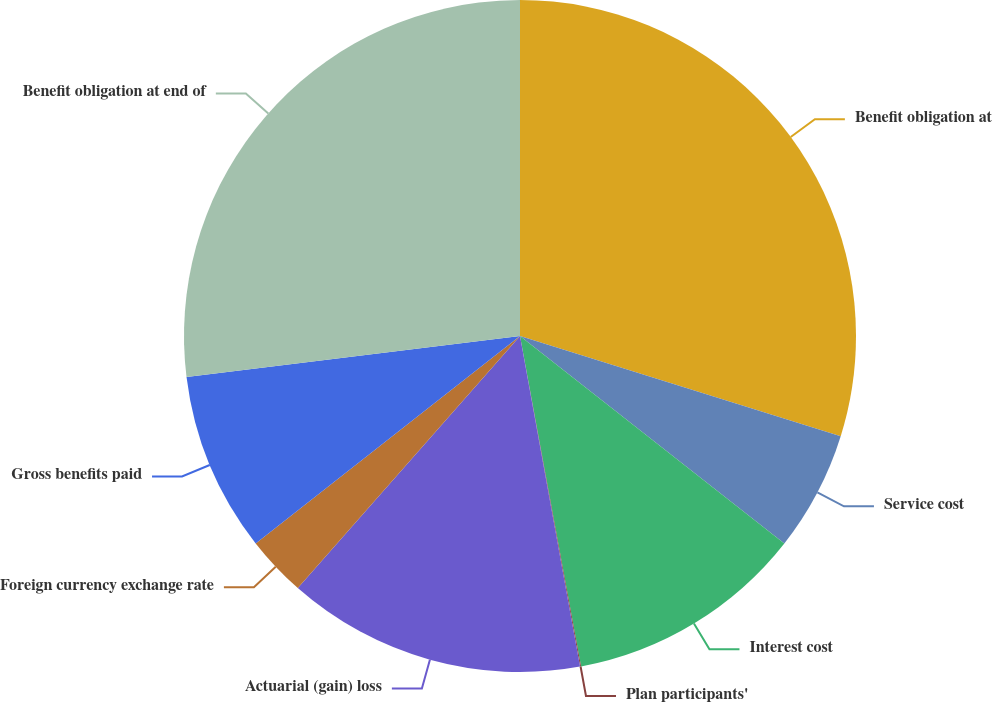<chart> <loc_0><loc_0><loc_500><loc_500><pie_chart><fcel>Benefit obligation at<fcel>Service cost<fcel>Interest cost<fcel>Plan participants'<fcel>Actuarial (gain) loss<fcel>Foreign currency exchange rate<fcel>Gross benefits paid<fcel>Benefit obligation at end of<nl><fcel>29.82%<fcel>5.77%<fcel>11.5%<fcel>0.05%<fcel>14.36%<fcel>2.91%<fcel>8.64%<fcel>26.95%<nl></chart> 